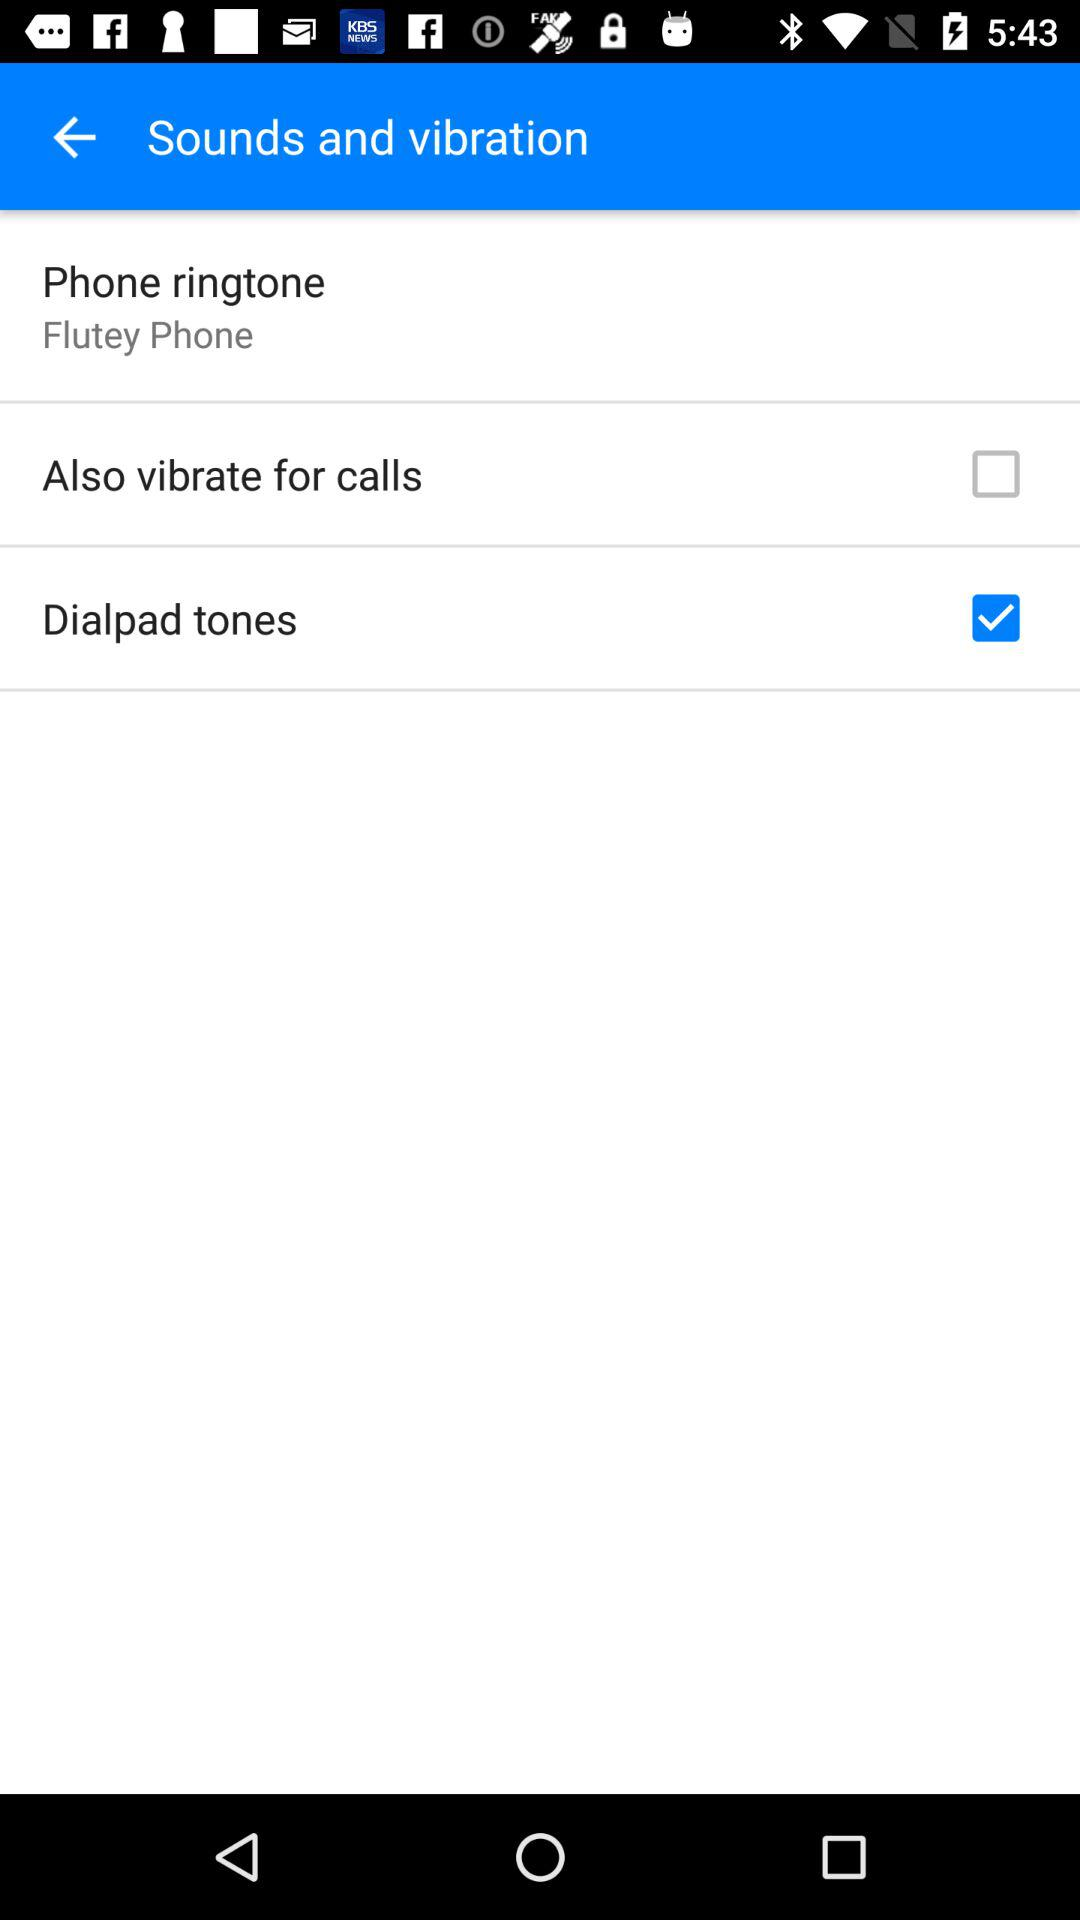What is the status of "Dialpad tones"? The status is "on". 